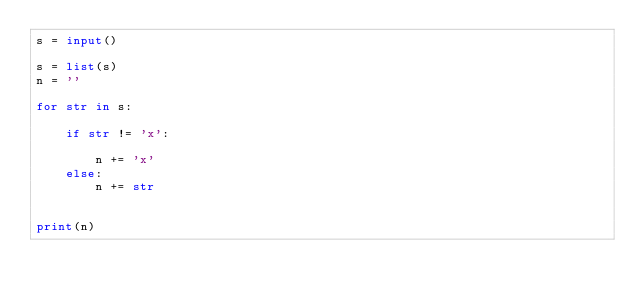<code> <loc_0><loc_0><loc_500><loc_500><_Python_>s = input()

s = list(s)
n = ''

for str in s:
    
    if str != 'x':

        n += 'x'
    else:
        n += str
    

print(n)</code> 